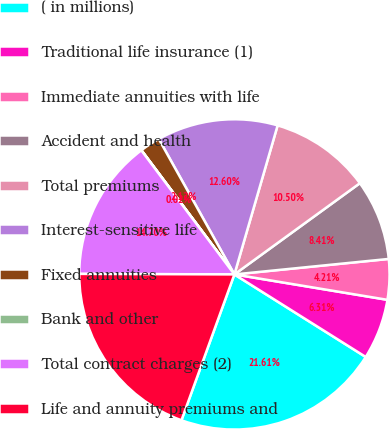Convert chart to OTSL. <chart><loc_0><loc_0><loc_500><loc_500><pie_chart><fcel>( in millions)<fcel>Traditional life insurance (1)<fcel>Immediate annuities with life<fcel>Accident and health<fcel>Total premiums<fcel>Interest-sensitive life<fcel>Fixed annuities<fcel>Bank and other<fcel>Total contract charges (2)<fcel>Life and annuity premiums and<nl><fcel>21.61%<fcel>6.31%<fcel>4.21%<fcel>8.41%<fcel>10.5%<fcel>12.6%<fcel>2.12%<fcel>0.02%<fcel>14.7%<fcel>19.51%<nl></chart> 